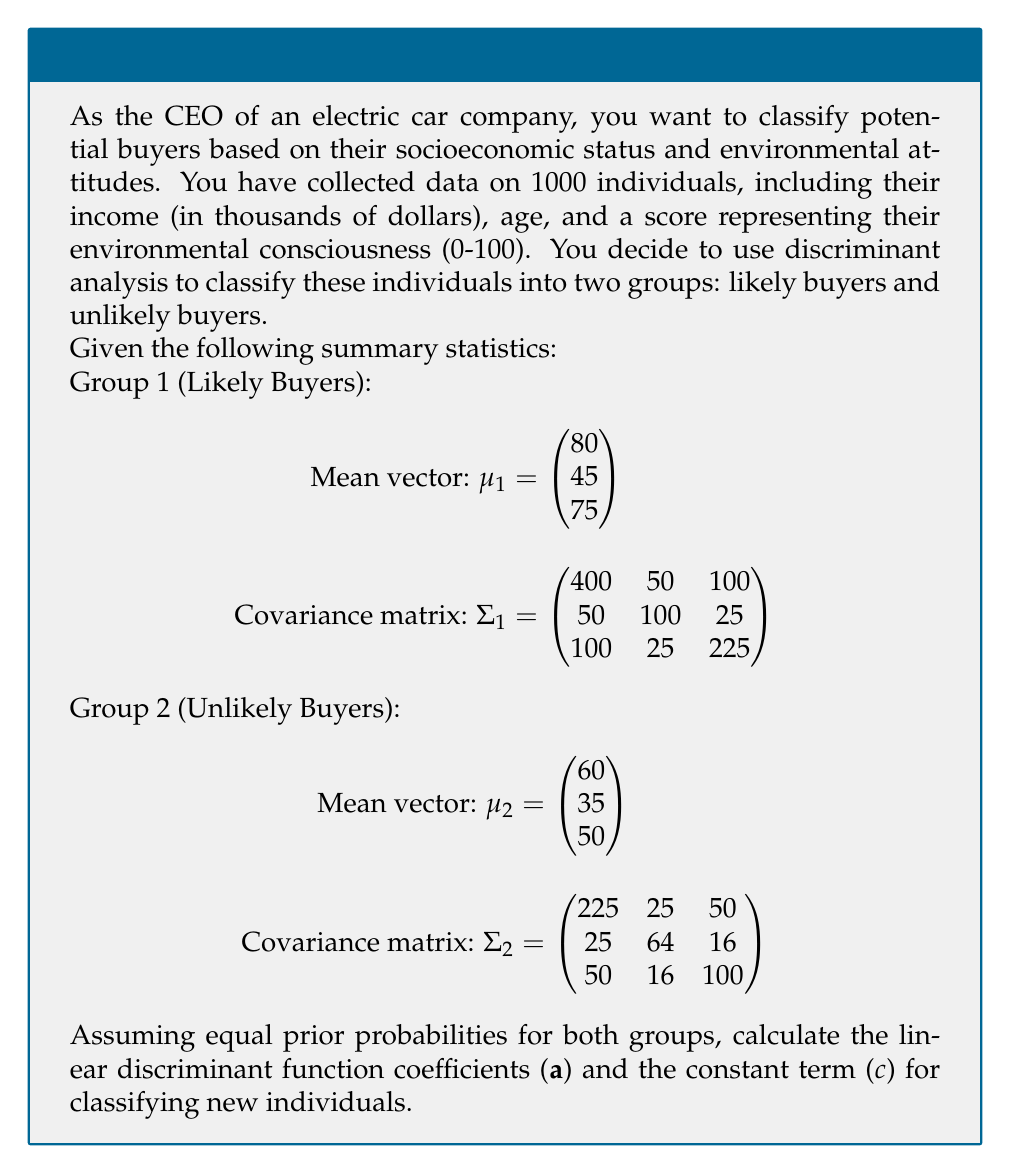Could you help me with this problem? To solve this problem, we'll use the linear discriminant analysis (LDA) approach. The steps are as follows:

1. Calculate the pooled covariance matrix $\Sigma$:
   $$\Sigma = \frac{1}{2}(\Sigma_1 + \Sigma_2) = \begin{pmatrix} 312.5 & 37.5 & 75 \\ 37.5 & 82 & 20.5 \\ 75 & 20.5 & 162.5 \end{pmatrix}$$

2. Calculate the inverse of the pooled covariance matrix $\Sigma^{-1}$:
   $$\Sigma^{-1} = \begin{pmatrix} 0.0036 & -0.0015 & -0.0015 \\ -0.0015 & 0.0132 & -0.0009 \\ -0.0015 & -0.0009 & 0.0069 \end{pmatrix}$$

3. Calculate the difference between mean vectors:
   $$\mu_1 - \mu_2 = \begin{pmatrix} 20 \\ 10 \\ 25 \end{pmatrix}$$

4. Calculate the linear discriminant function coefficients (a):
   $$a = \Sigma^{-1}(\mu_1 - \mu_2) = \begin{pmatrix} 0.0036 & -0.0015 & -0.0015 \\ -0.0015 & 0.0132 & -0.0009 \\ -0.0015 & -0.0009 & 0.0069 \end{pmatrix} \begin{pmatrix} 20 \\ 10 \\ 25 \end{pmatrix} = \begin{pmatrix} 0.0370 \\ 0.0935 \\ 0.1560 \end{pmatrix}$$

5. Calculate the constant term (c):
   $$c = -\frac{1}{2}(\mu_1 + \mu_2)^T a = -\frac{1}{2}\begin{pmatrix} 140 & 80 & 125 \end{pmatrix} \begin{pmatrix} 0.0370 \\ 0.0935 \\ 0.1560 \end{pmatrix} = -13.7375$$

The linear discriminant function is:
$$f(x) = a^T x + c = 0.0370x_1 + 0.0935x_2 + 0.1560x_3 - 13.7375$$

Where $x_1$ is income, $x_2$ is age, and $x_3$ is environmental consciousness score.
Answer: $a = (0.0370, 0.0935, 0.1560)^T$, $c = -13.7375$ 